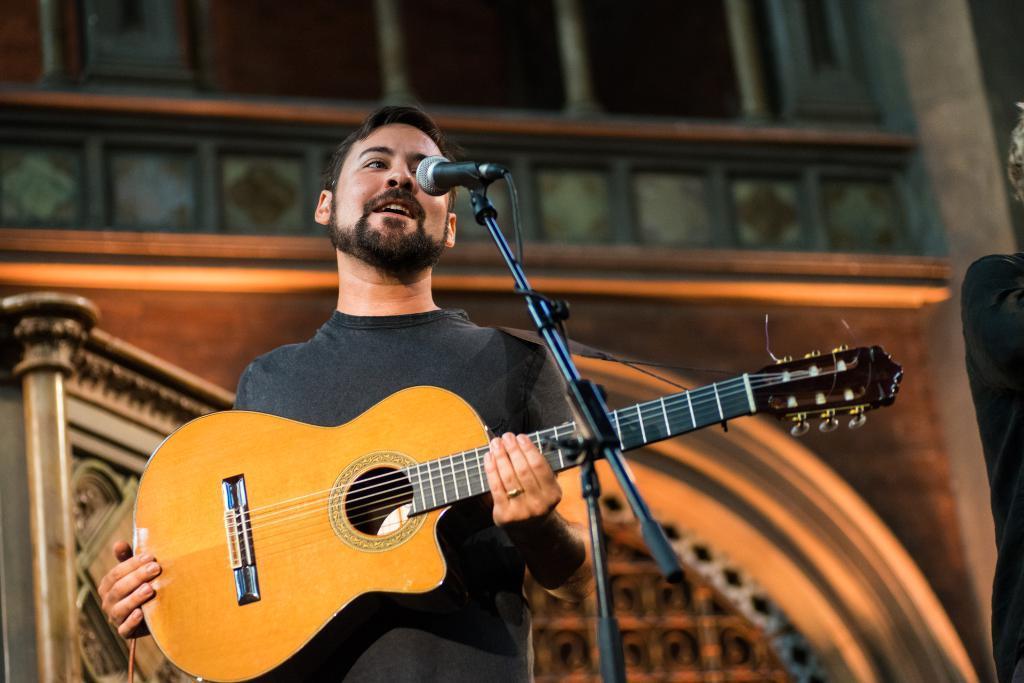Please provide a concise description of this image. There is a man playing guitar and singing in a microphone. 